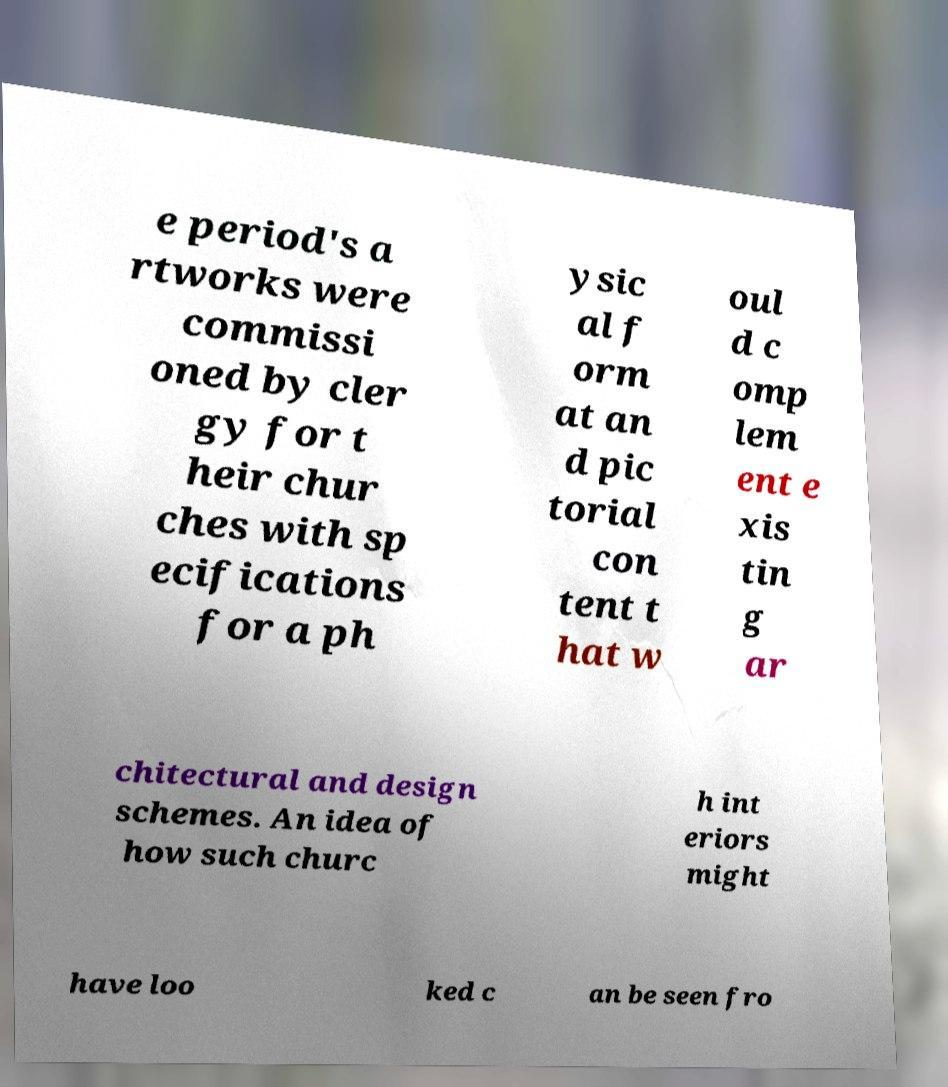Could you assist in decoding the text presented in this image and type it out clearly? e period's a rtworks were commissi oned by cler gy for t heir chur ches with sp ecifications for a ph ysic al f orm at an d pic torial con tent t hat w oul d c omp lem ent e xis tin g ar chitectural and design schemes. An idea of how such churc h int eriors might have loo ked c an be seen fro 